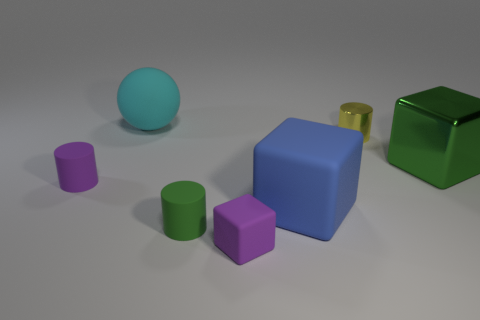Subtract all large green cubes. How many cubes are left? 2 Subtract all gray cylinders. Subtract all blue balls. How many cylinders are left? 3 Add 1 large blue things. How many objects exist? 8 Subtract all cylinders. How many objects are left? 4 Add 5 cyan objects. How many cyan objects are left? 6 Add 7 small yellow objects. How many small yellow objects exist? 8 Subtract 0 cyan blocks. How many objects are left? 7 Subtract all cyan shiny things. Subtract all tiny cylinders. How many objects are left? 4 